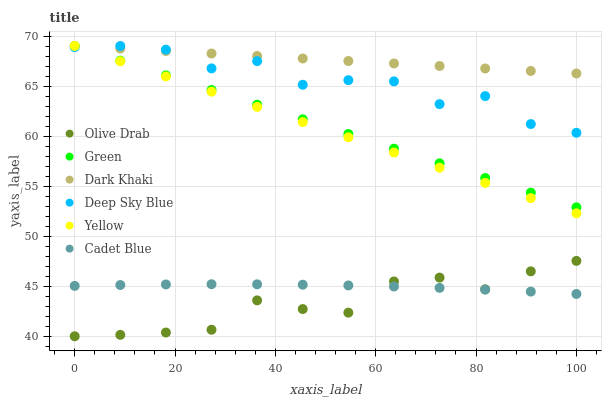Does Olive Drab have the minimum area under the curve?
Answer yes or no. Yes. Does Dark Khaki have the maximum area under the curve?
Answer yes or no. Yes. Does Yellow have the minimum area under the curve?
Answer yes or no. No. Does Yellow have the maximum area under the curve?
Answer yes or no. No. Is Green the smoothest?
Answer yes or no. Yes. Is Deep Sky Blue the roughest?
Answer yes or no. Yes. Is Yellow the smoothest?
Answer yes or no. No. Is Yellow the roughest?
Answer yes or no. No. Does Olive Drab have the lowest value?
Answer yes or no. Yes. Does Yellow have the lowest value?
Answer yes or no. No. Does Deep Sky Blue have the highest value?
Answer yes or no. Yes. Does Olive Drab have the highest value?
Answer yes or no. No. Is Olive Drab less than Yellow?
Answer yes or no. Yes. Is Green greater than Cadet Blue?
Answer yes or no. Yes. Does Dark Khaki intersect Deep Sky Blue?
Answer yes or no. Yes. Is Dark Khaki less than Deep Sky Blue?
Answer yes or no. No. Is Dark Khaki greater than Deep Sky Blue?
Answer yes or no. No. Does Olive Drab intersect Yellow?
Answer yes or no. No. 